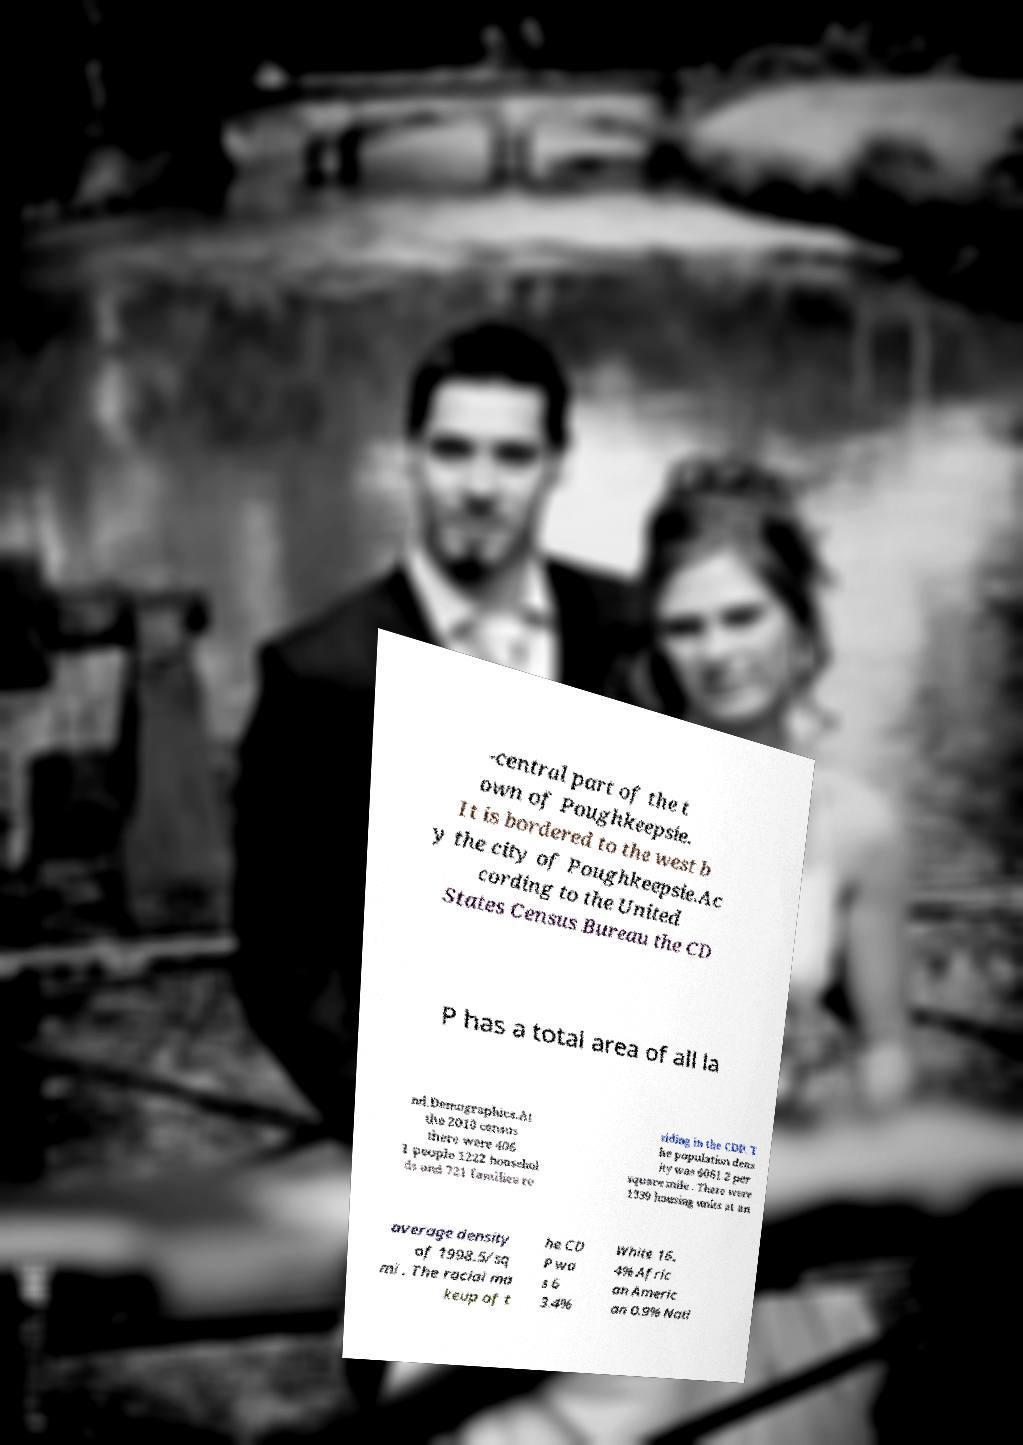What messages or text are displayed in this image? I need them in a readable, typed format. -central part of the t own of Poughkeepsie. It is bordered to the west b y the city of Poughkeepsie.Ac cording to the United States Census Bureau the CD P has a total area of all la nd.Demographics.At the 2010 census there were 406 1 people 1222 househol ds and 721 families re siding in the CDP. T he population dens ity was 6061.2 per square mile . There were 1339 housing units at an average density of 1998.5/sq mi . The racial ma keup of t he CD P wa s 6 3.4% White 16. 4% Afric an Americ an 0.9% Nati 